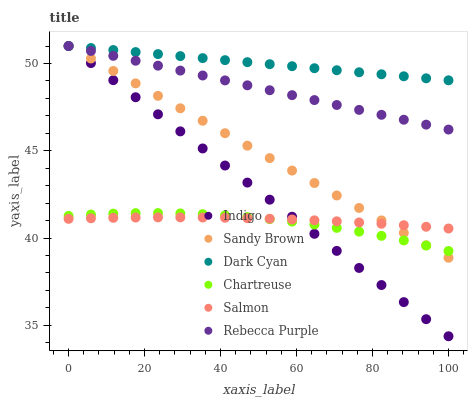Does Chartreuse have the minimum area under the curve?
Answer yes or no. Yes. Does Dark Cyan have the maximum area under the curve?
Answer yes or no. Yes. Does Salmon have the minimum area under the curve?
Answer yes or no. No. Does Salmon have the maximum area under the curve?
Answer yes or no. No. Is Rebecca Purple the smoothest?
Answer yes or no. Yes. Is Chartreuse the roughest?
Answer yes or no. Yes. Is Salmon the smoothest?
Answer yes or no. No. Is Salmon the roughest?
Answer yes or no. No. Does Indigo have the lowest value?
Answer yes or no. Yes. Does Salmon have the lowest value?
Answer yes or no. No. Does Sandy Brown have the highest value?
Answer yes or no. Yes. Does Chartreuse have the highest value?
Answer yes or no. No. Is Chartreuse less than Dark Cyan?
Answer yes or no. Yes. Is Dark Cyan greater than Chartreuse?
Answer yes or no. Yes. Does Indigo intersect Sandy Brown?
Answer yes or no. Yes. Is Indigo less than Sandy Brown?
Answer yes or no. No. Is Indigo greater than Sandy Brown?
Answer yes or no. No. Does Chartreuse intersect Dark Cyan?
Answer yes or no. No. 